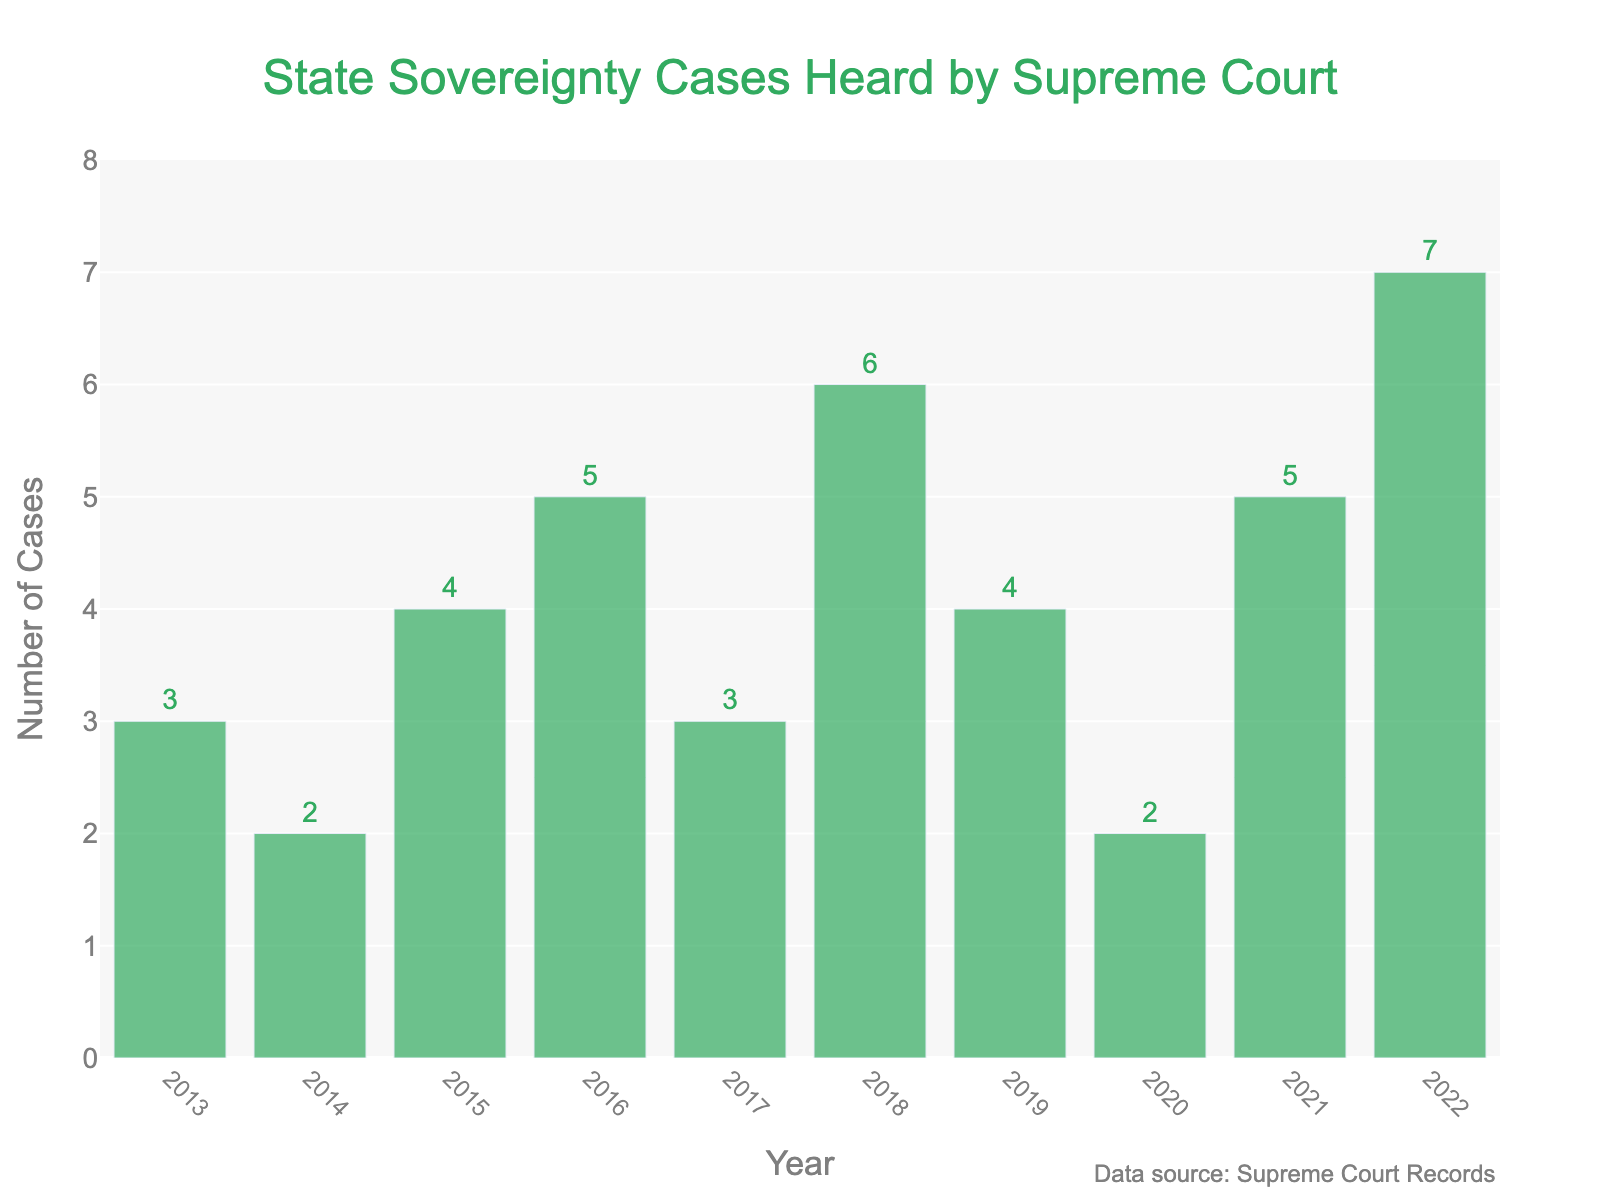What's the total number of state sovereignty cases heard by the Supreme Court over the past decade? Add the number of cases for each year: 3 (2013) + 2 (2014) + 4 (2015) + 5 (2016) + 3 (2017) + 6 (2018) + 4 (2019) + 2 (2020) + 5 (2021) + 7 (2022). Summing these gives 41.
Answer: 41 Which year had the highest number of state sovereignty cases? Identify the year with the tallest bar. The tallest bar corresponds to the year 2022 with 7 cases.
Answer: 2022 What's the average number of state sovereignty cases per year over the decade? Divide the total number of cases (41) by the number of years (10): 41 / 10 = 4.1.
Answer: 4.1 Which year had the lowest number of state sovereignty cases? Identify the year with the shortest bar. The shortest bar corresponds to the years 2014 and 2020, each having 2 cases.
Answer: 2014 and 2020 By how many cases did the number of state sovereignty cases increase from 2020 to 2022? Subtract the number of cases in 2020 (2) from the number in 2022 (7): 7 - 2 = 5.
Answer: 5 How many years had more than 4 state sovereignty cases? Count the bars representing more than 4 cases: 2016 (5), 2018 (6), 2021 (5), 2022 (7). There are 4 years.
Answer: 4 Compare the number of cases in 2017 to 2018. How many more cases were there in 2018? Subtract the number of cases in 2017 (3) from the number in 2018 (6): 6 - 3 = 3.
Answer: 3 What is the difference between the highest and lowest number of state sovereignty cases heard in a year? Subtract the lowest value (2 in 2014 and 2020) from the highest value (7 in 2022): 7 - 2 = 5.
Answer: 5 How many consecutive years had either an increase or a decrease in the number of cases? Review the changes each year: Review each year comparison one by one. The longest sequence is from 2014 to 2016, 2016 to 2018, and 2020 to 2022. These sequences have 2-3 years consecutively increasing or decreasing. Identifying the longest change pattern requires detailed counting.
Answer: 3 In which years did the number of cases remain the same as in any previous year? Identify any bars of equal height: 2014 and 2020 both have 2 cases, and other years do not repeat counts.
Answer: 2014 and 2020 